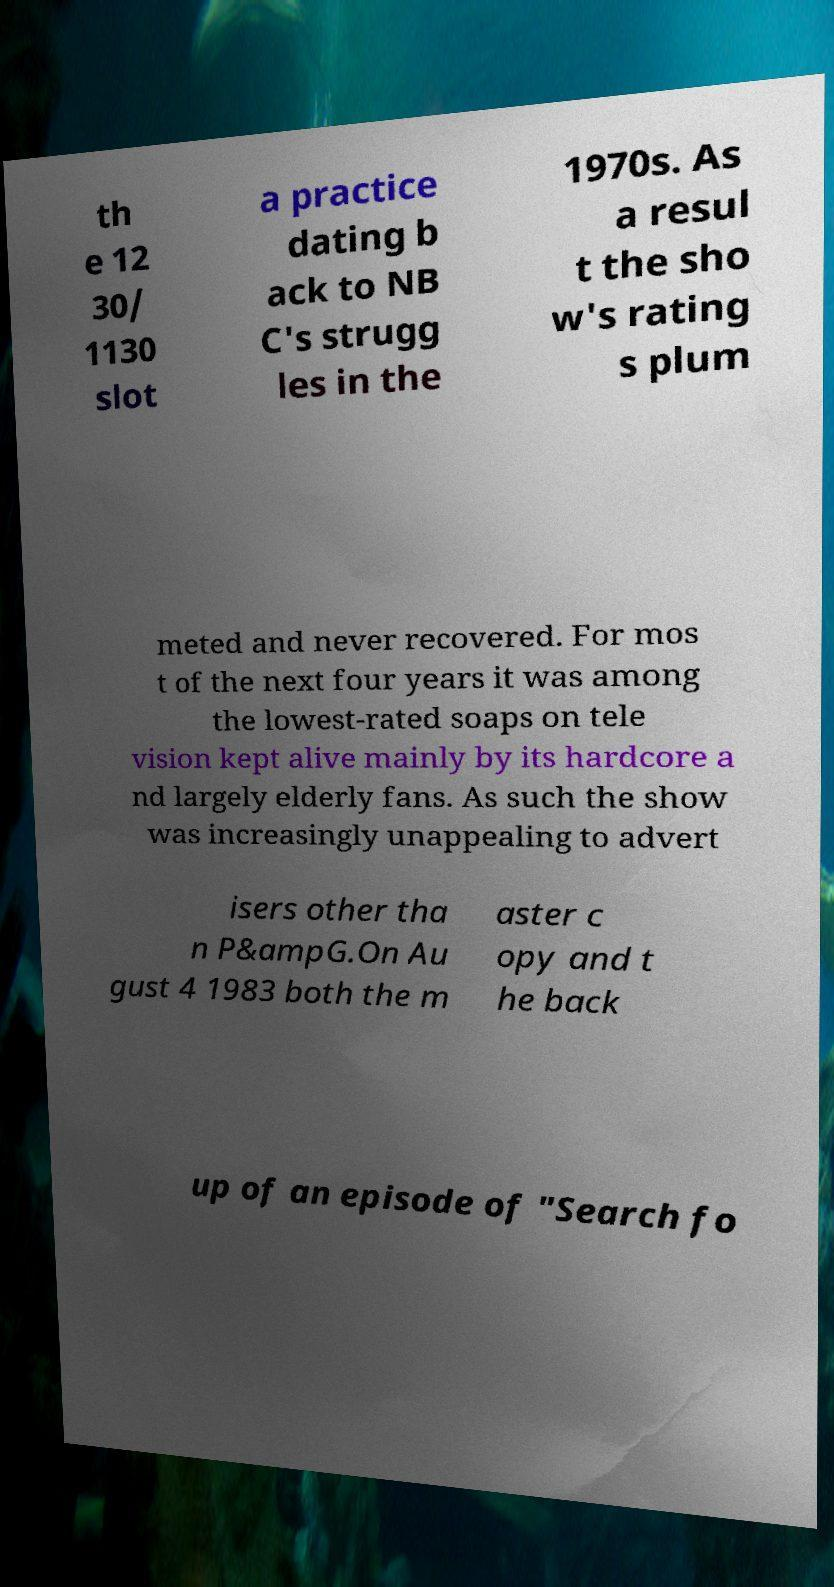For documentation purposes, I need the text within this image transcribed. Could you provide that? th e 12 30/ 1130 slot a practice dating b ack to NB C's strugg les in the 1970s. As a resul t the sho w's rating s plum meted and never recovered. For mos t of the next four years it was among the lowest-rated soaps on tele vision kept alive mainly by its hardcore a nd largely elderly fans. As such the show was increasingly unappealing to advert isers other tha n P&ampG.On Au gust 4 1983 both the m aster c opy and t he back up of an episode of "Search fo 